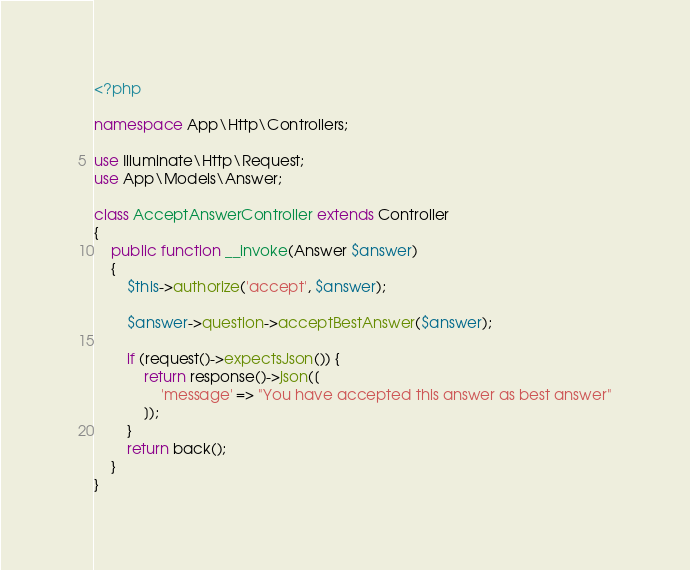<code> <loc_0><loc_0><loc_500><loc_500><_PHP_><?php

namespace App\Http\Controllers;

use Illuminate\Http\Request;
use App\Models\Answer;

class AcceptAnswerController extends Controller
{
    public function __invoke(Answer $answer)
    {
        $this->authorize('accept', $answer);

        $answer->question->acceptBestAnswer($answer);

        if (request()->expectsJson()) {
            return response()->json([
                'message' => "You have accepted this answer as best answer"
            ]);
        }
        return back();
    }
}
</code> 